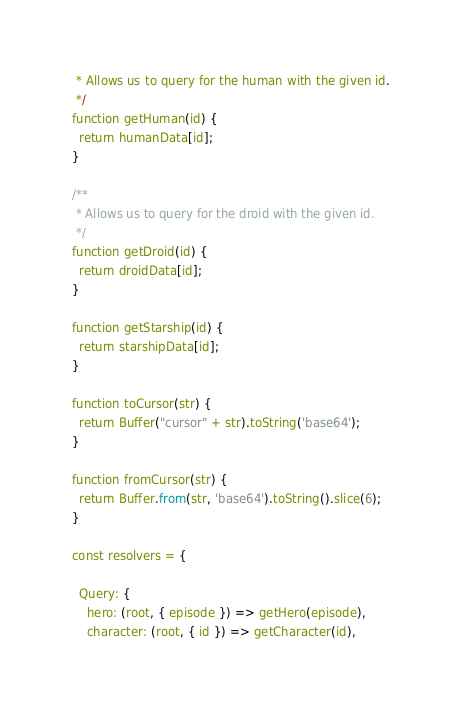Convert code to text. <code><loc_0><loc_0><loc_500><loc_500><_JavaScript_> * Allows us to query for the human with the given id.
 */
function getHuman(id) {
  return humanData[id];
}

/**
 * Allows us to query for the droid with the given id.
 */
function getDroid(id) {
  return droidData[id];
}

function getStarship(id) {
  return starshipData[id];
}

function toCursor(str) {
  return Buffer("cursor" + str).toString('base64');
}

function fromCursor(str) {
  return Buffer.from(str, 'base64').toString().slice(6);
}

const resolvers = {

  Query: {
    hero: (root, { episode }) => getHero(episode),
    character: (root, { id }) => getCharacter(id),</code> 